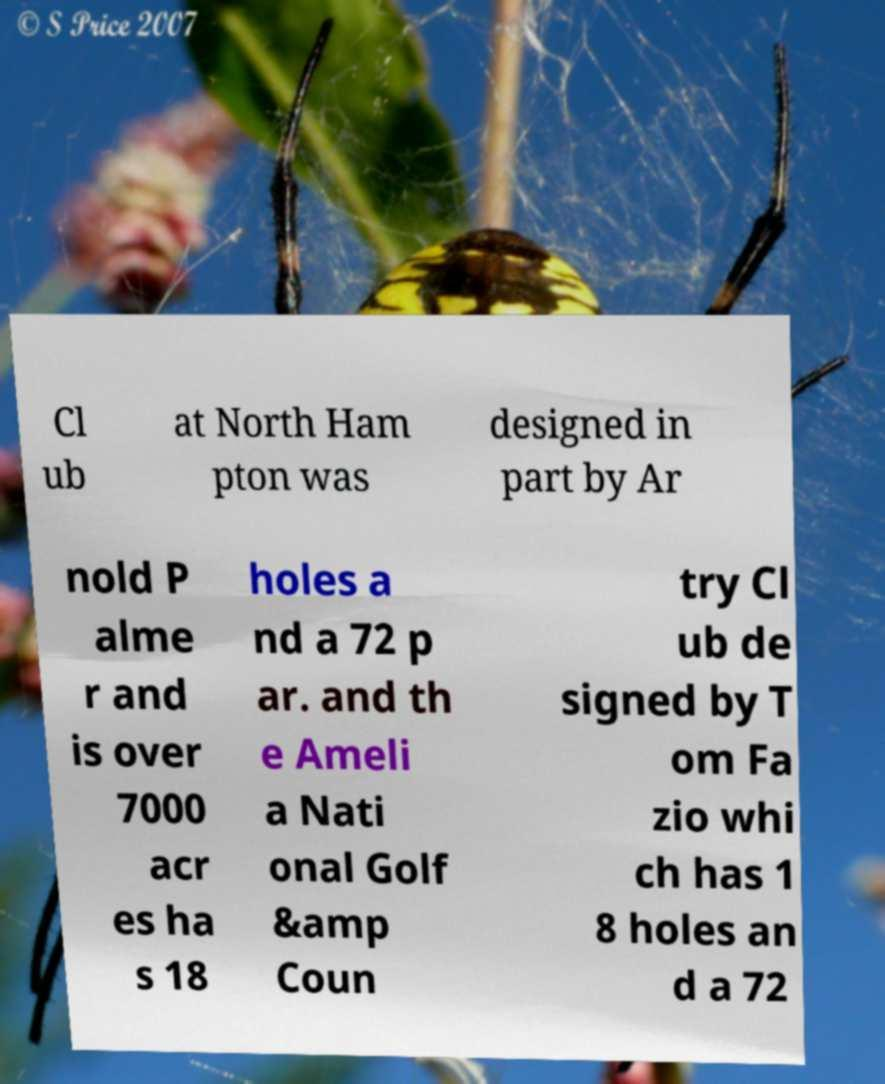Can you accurately transcribe the text from the provided image for me? Cl ub at North Ham pton was designed in part by Ar nold P alme r and is over 7000 acr es ha s 18 holes a nd a 72 p ar. and th e Ameli a Nati onal Golf &amp Coun try Cl ub de signed by T om Fa zio whi ch has 1 8 holes an d a 72 